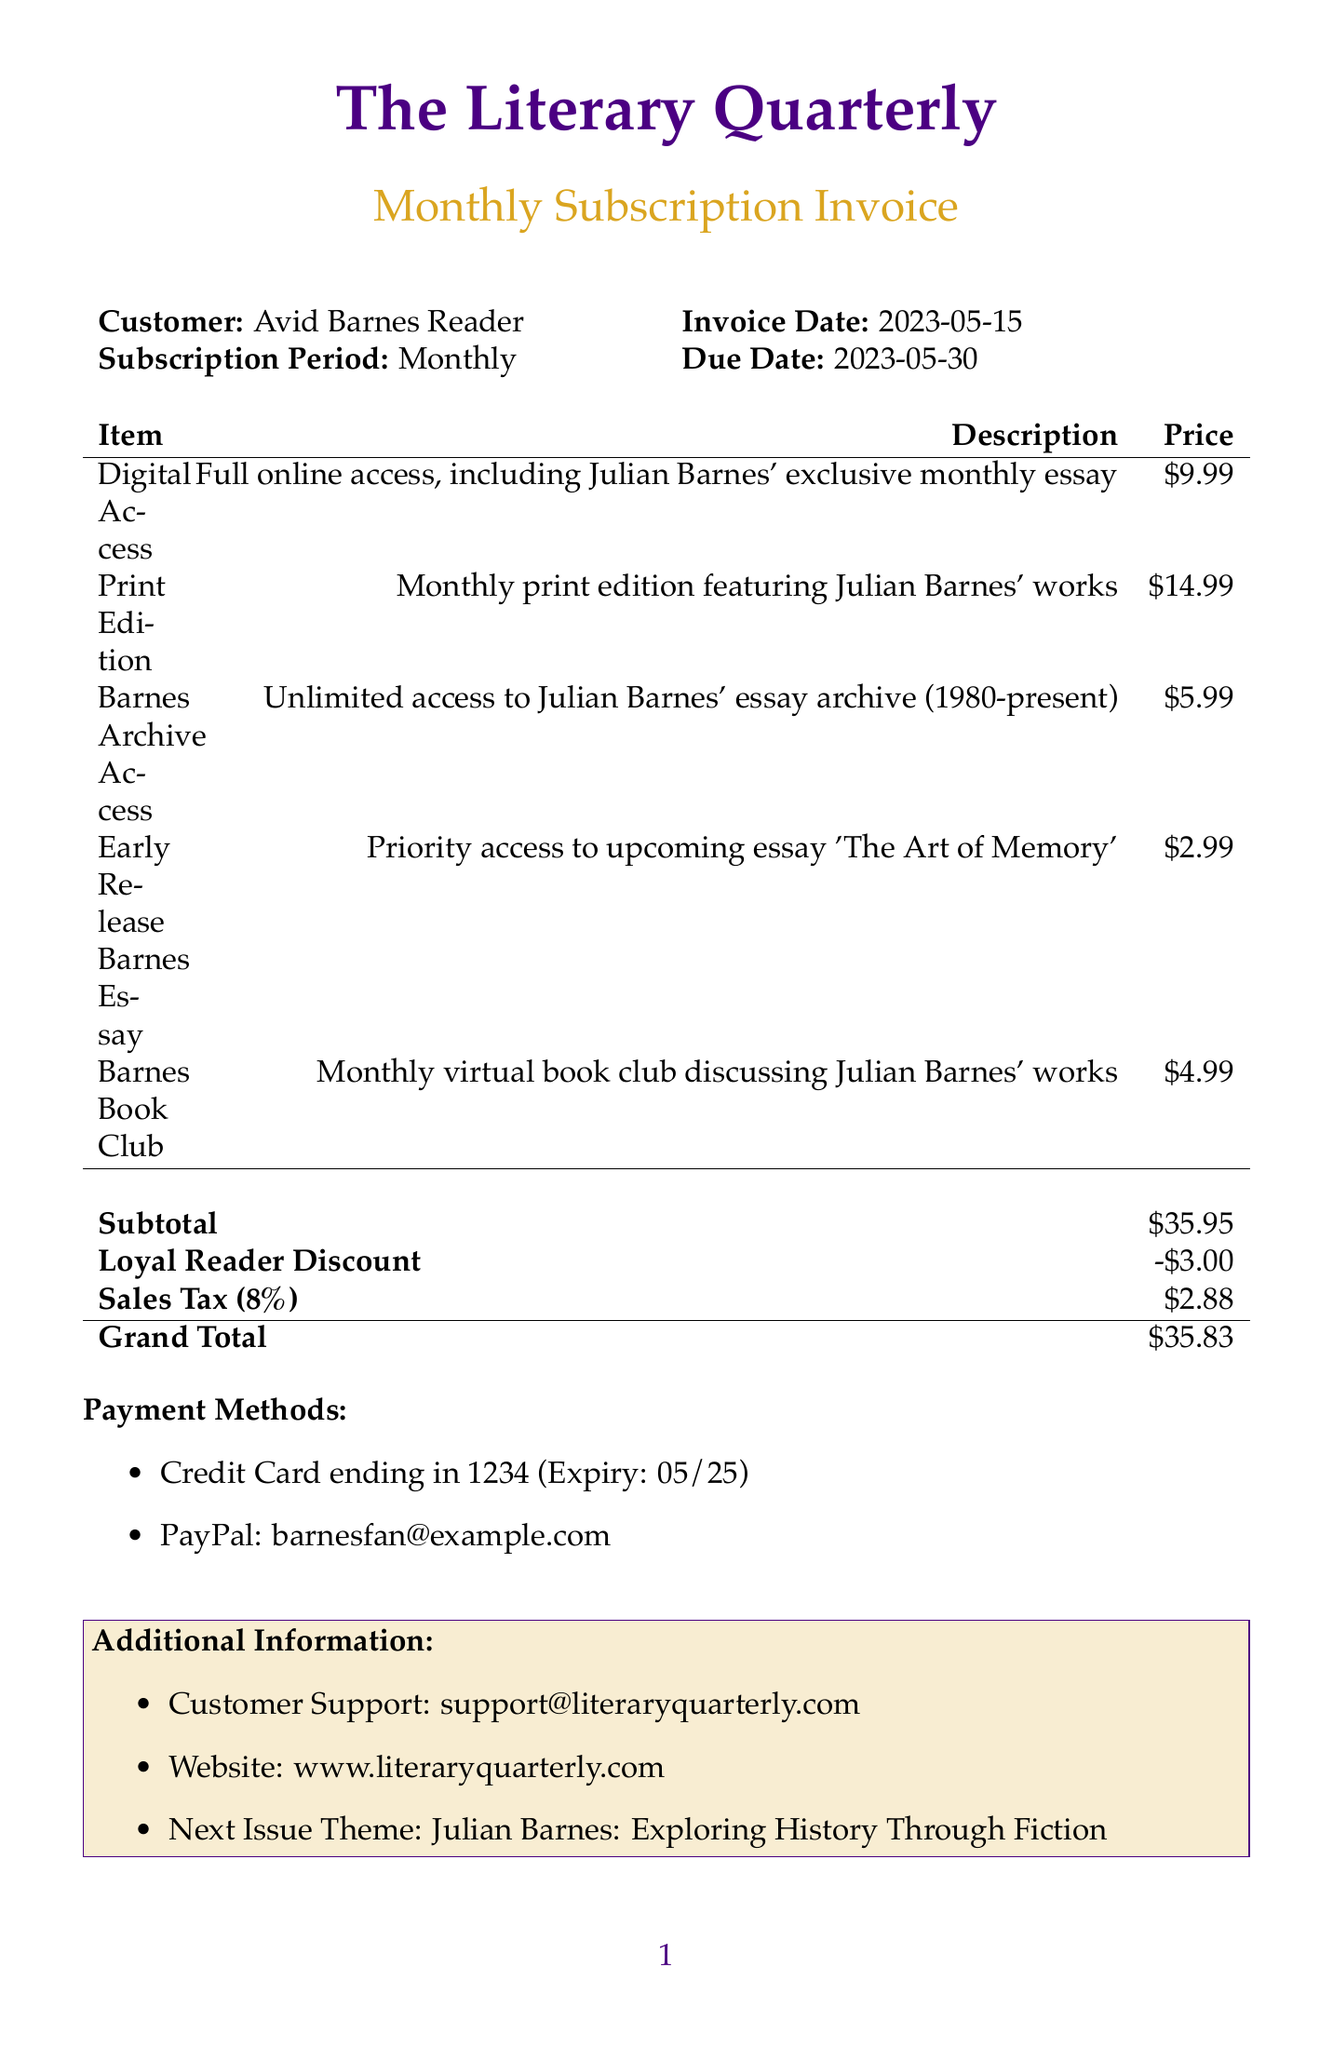What is the magazine name? The magazine name is stated at the top of the document as part of the invoice heading.
Answer: The Literary Quarterly What is the invoice date? The invoice date is displayed next to the customer's name and is specified as the date the invoice was generated.
Answer: 2023-05-15 How much is the digital access fee? The digital access fee is listed in the breakdown of subscription items with its corresponding price.
Answer: $9.99 What is the amount of the Loyal Reader Discount? The Loyal Reader Discount is explicitly mentioned in the discounts section of the invoice, detailing the amount of deduction.
Answer: -$3.00 What is the grand total due? The grand total is the final amount due after accounting for the subtotal, discounts, and taxes, clearly stated at the end of the invoice.
Answer: $35.83 How many payment methods are provided? The number of payment methods can be counted from the payment methods section.
Answer: 2 What theme is featured in the next issue? The next issue theme is mentioned in additional information that gives a hint about upcoming content.
Answer: Julian Barnes: Exploring History Through Fiction What does the Barnes Archive Access provide? The description for Barnes Archive Access outlines what is included in this item.
Answer: Unlimited access to Julian Barnes' essay archive (1980-present) What is the price of the Early Release Barnes Essay? The price for the Early Release Barnes Essay can be found in the breakdown of additional features listed in the invoice.
Answer: $2.99 